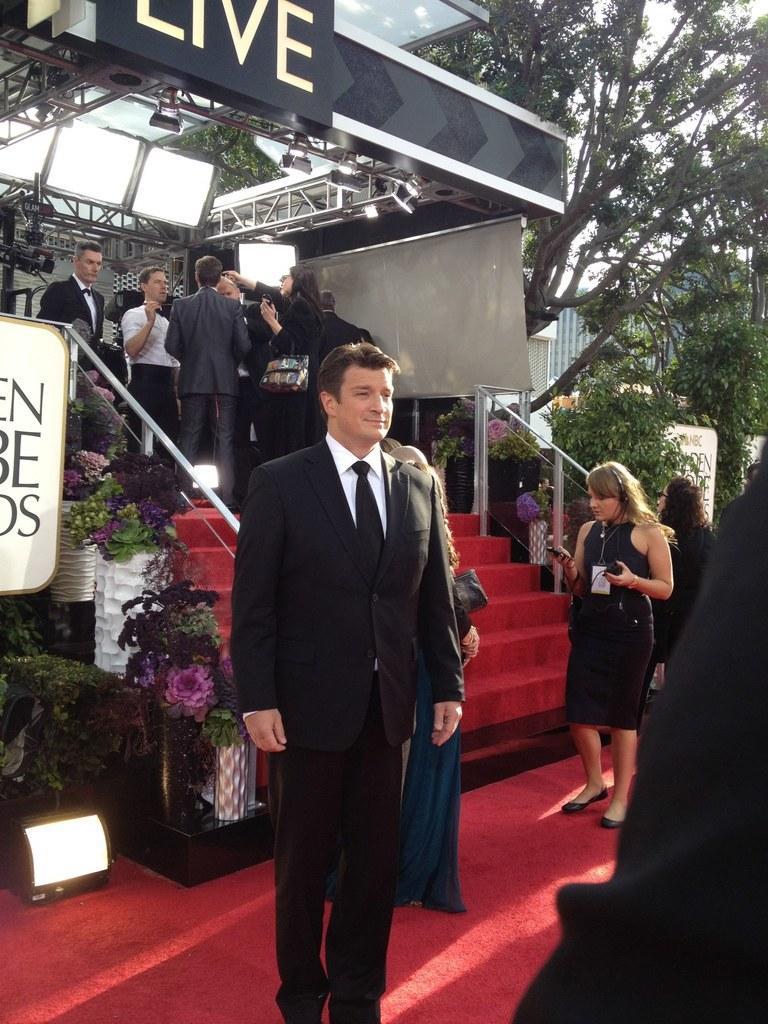Can you describe this image briefly? In this image I can see a person wearing black and white colored dress is stunning. I can see the red colored stairs and floor, the railing, few plants, few flowers, few metal rods, few lights, few persons, few trees which are green in color and the sky. 